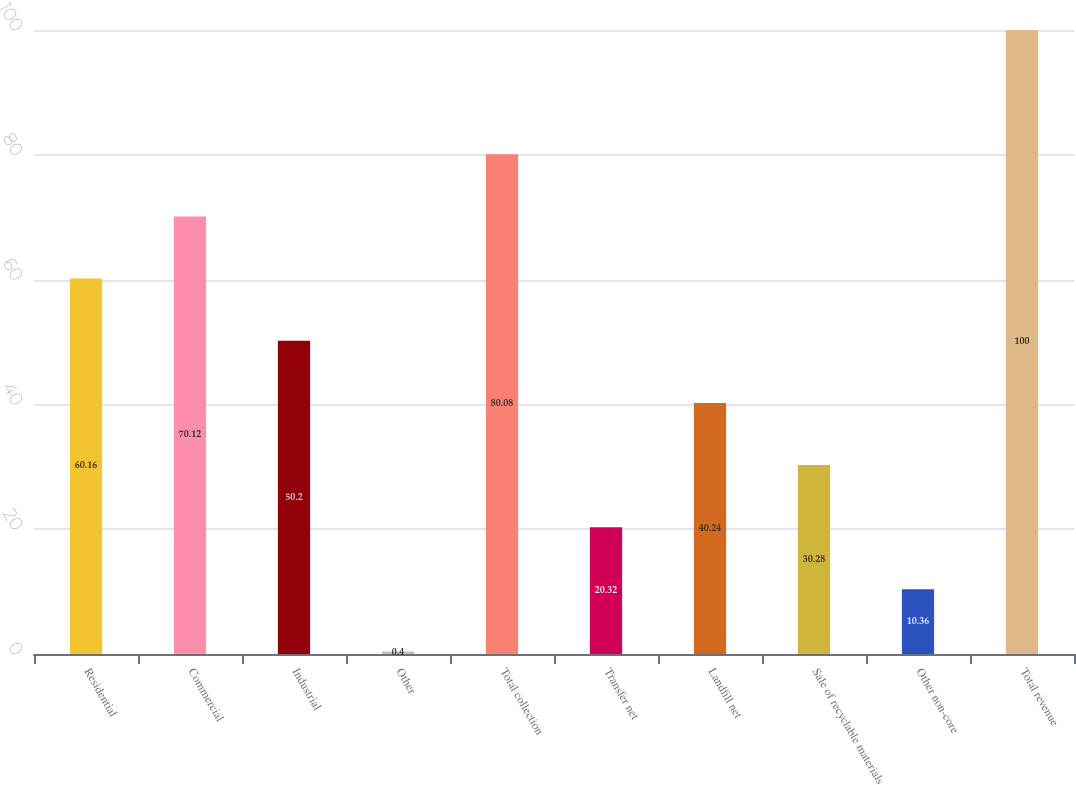Convert chart. <chart><loc_0><loc_0><loc_500><loc_500><bar_chart><fcel>Residential<fcel>Commercial<fcel>Industrial<fcel>Other<fcel>Total collection<fcel>Transfer net<fcel>Landfill net<fcel>Sale of recyclable materials<fcel>Other non-core<fcel>Total revenue<nl><fcel>60.16<fcel>70.12<fcel>50.2<fcel>0.4<fcel>80.08<fcel>20.32<fcel>40.24<fcel>30.28<fcel>10.36<fcel>100<nl></chart> 